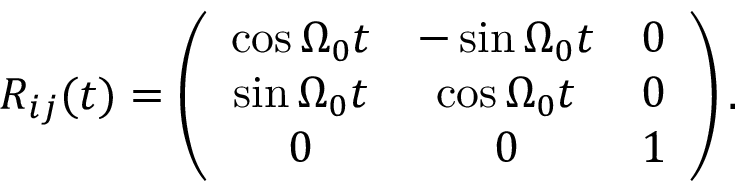Convert formula to latex. <formula><loc_0><loc_0><loc_500><loc_500>\begin{array} { r } { R _ { i j } ( t ) = \left ( \begin{array} { c c c } { \cos \Omega _ { 0 } t } & { - \sin \Omega _ { 0 } t } & { 0 } \\ { \sin \Omega _ { 0 } t } & { \cos \Omega _ { 0 } t } & { 0 } \\ { 0 } & { 0 } & { 1 } \end{array} \right ) . } \end{array}</formula> 